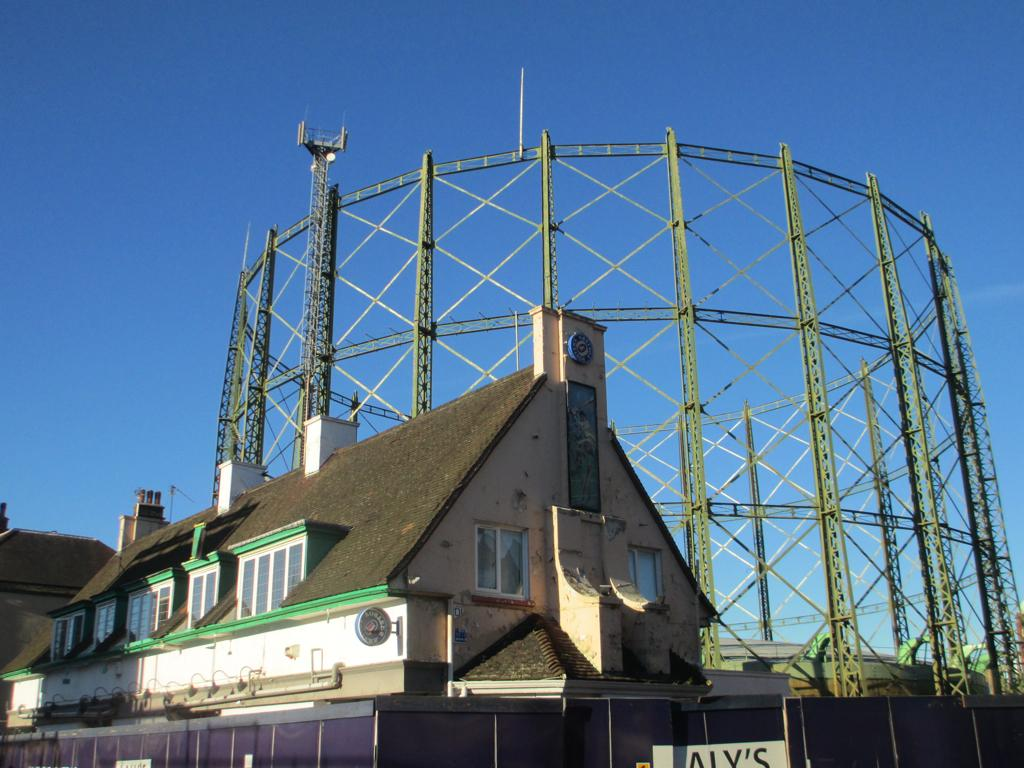What type of structure is in the image? There is a shelter house in the image. Where is the shelter house located in relation to other structures? The shelter house is in front of a tower. What can be seen in the background of the image? There is a sky visible in the background of the image. Can you see any fights happening between pests in the image? There is no mention of any fights or pests in the image; it features a shelter house in front of a tower with a visible sky in the background. 